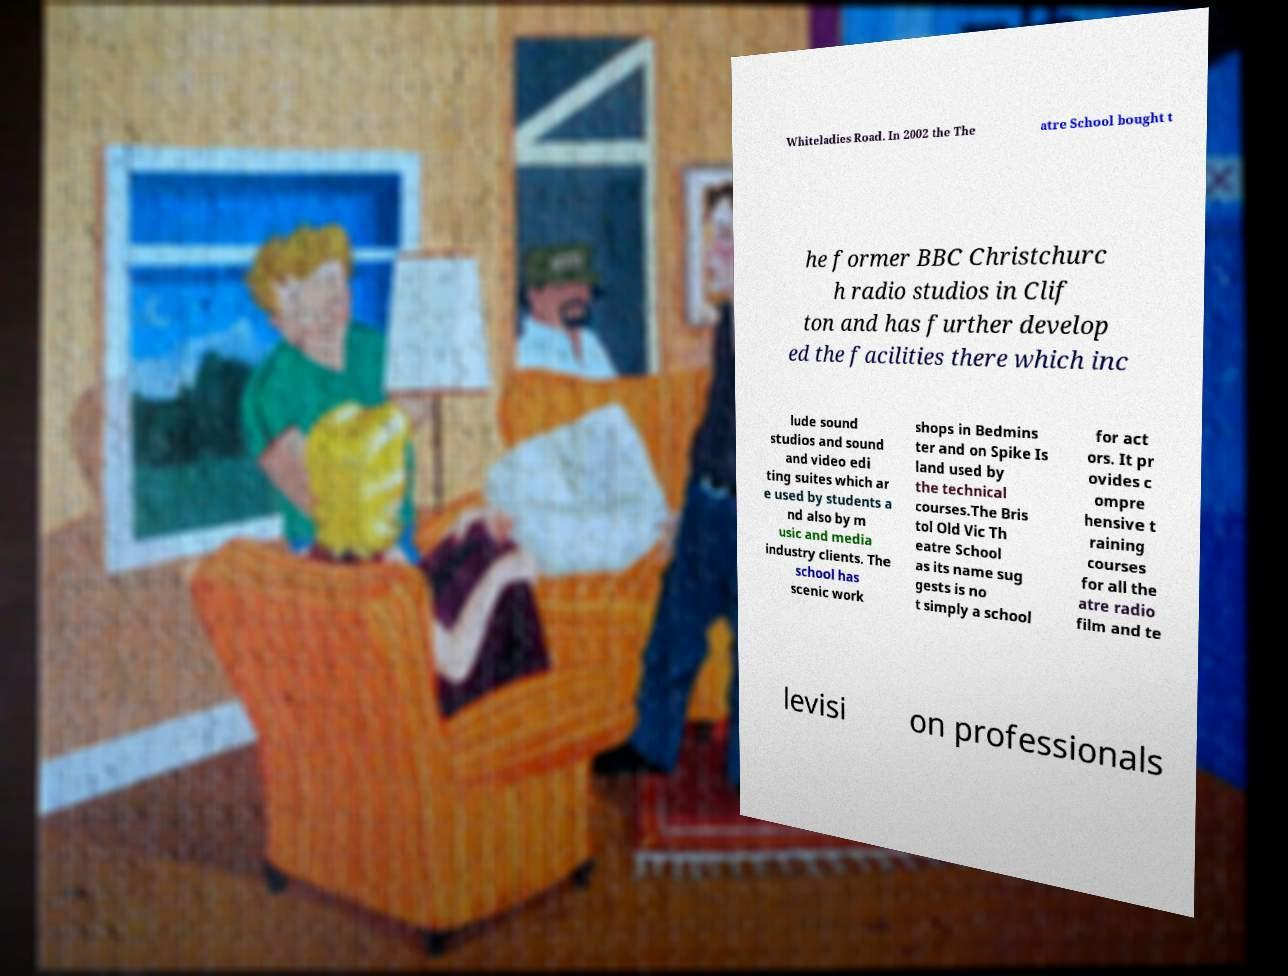I need the written content from this picture converted into text. Can you do that? Whiteladies Road. In 2002 the The atre School bought t he former BBC Christchurc h radio studios in Clif ton and has further develop ed the facilities there which inc lude sound studios and sound and video edi ting suites which ar e used by students a nd also by m usic and media industry clients. The school has scenic work shops in Bedmins ter and on Spike Is land used by the technical courses.The Bris tol Old Vic Th eatre School as its name sug gests is no t simply a school for act ors. It pr ovides c ompre hensive t raining courses for all the atre radio film and te levisi on professionals 